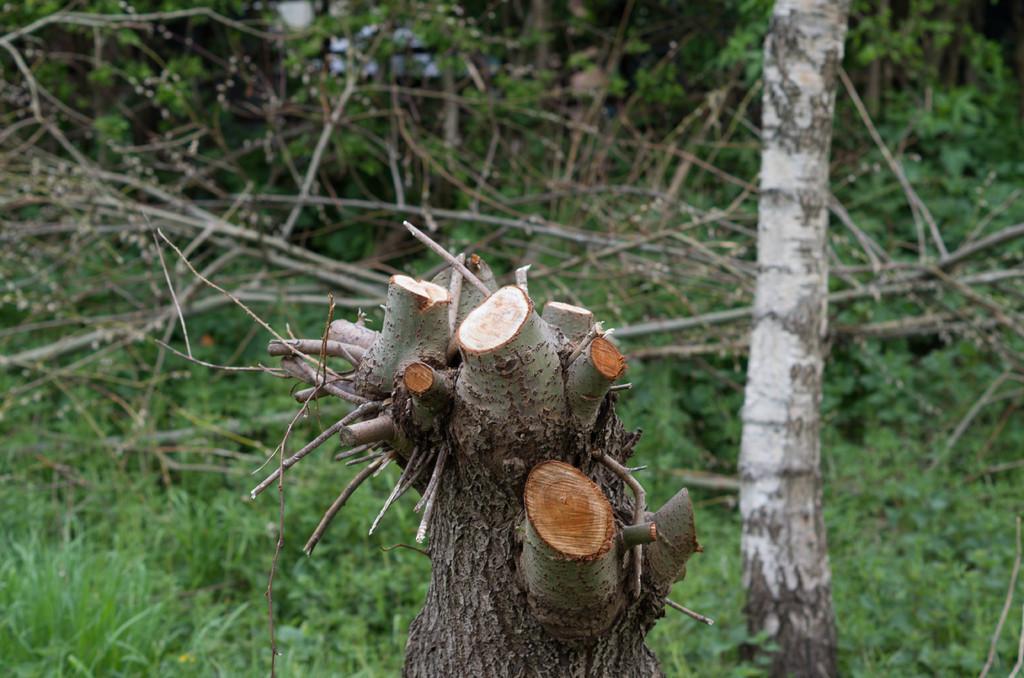Could you give a brief overview of what you see in this image? There is a stem of a tree as we can see at the bottom of this image and it seems like there are some plants in the background. 